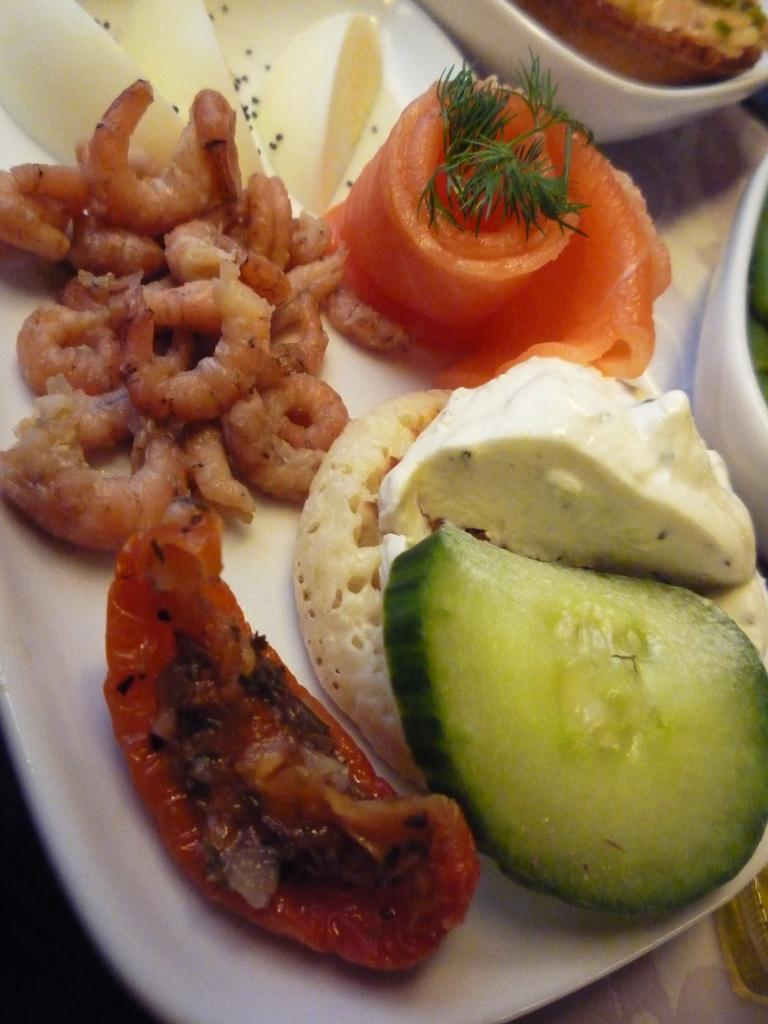What types of food items can be seen in the image? There are food items in the image, but their specific types are not mentioned. How many bowls with food are visible in the image? There are two bowls with food in the image. Where are the bowls placed? The bowls are on a plate. What is the plate resting on? The plate is on a platform. Where is the lunchroom located in the image? There is no mention of a lunchroom in the image or the provided facts. 